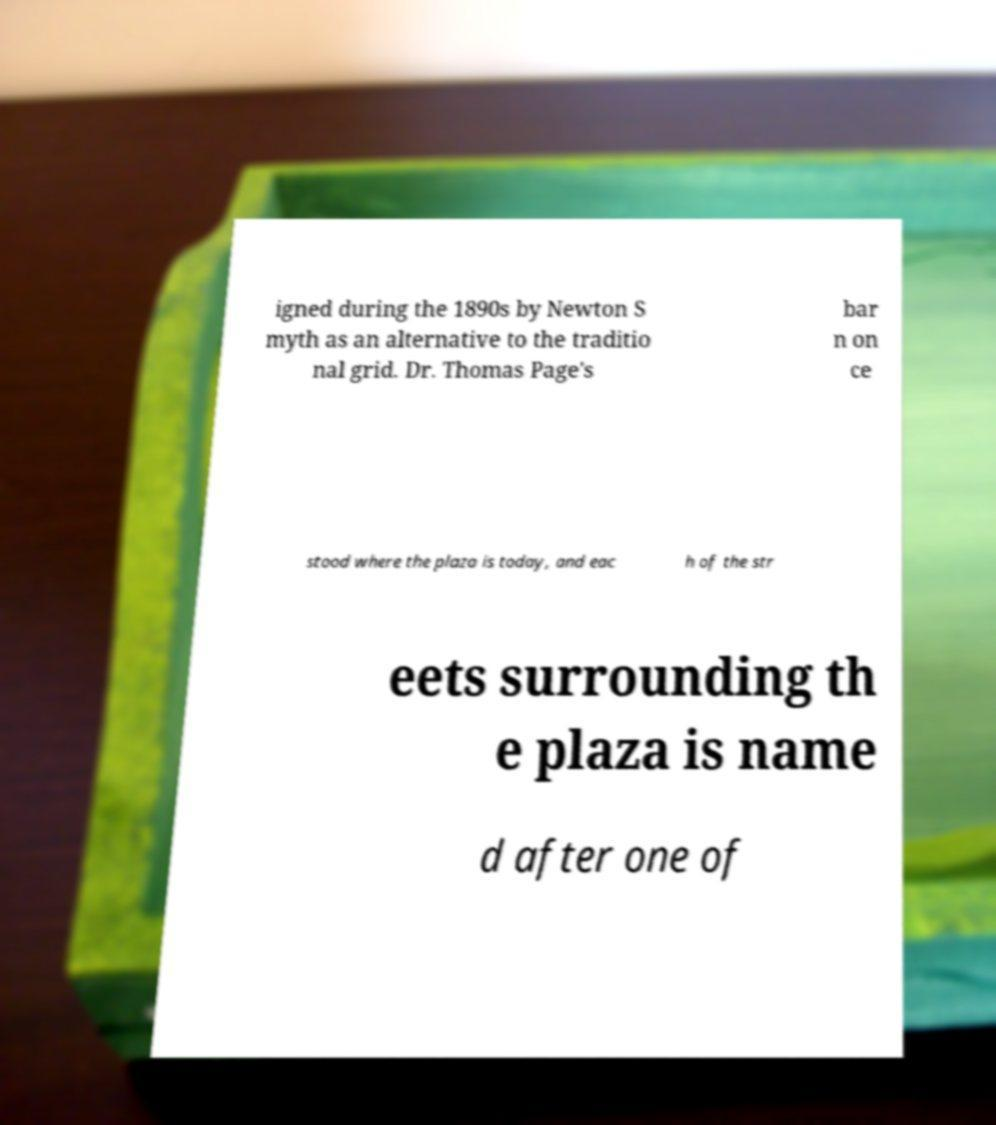Can you read and provide the text displayed in the image?This photo seems to have some interesting text. Can you extract and type it out for me? igned during the 1890s by Newton S myth as an alternative to the traditio nal grid. Dr. Thomas Page's bar n on ce stood where the plaza is today, and eac h of the str eets surrounding th e plaza is name d after one of 